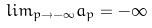Convert formula to latex. <formula><loc_0><loc_0><loc_500><loc_500>l i m _ { p \rightarrow - \infty } a _ { p } = - \infty</formula> 